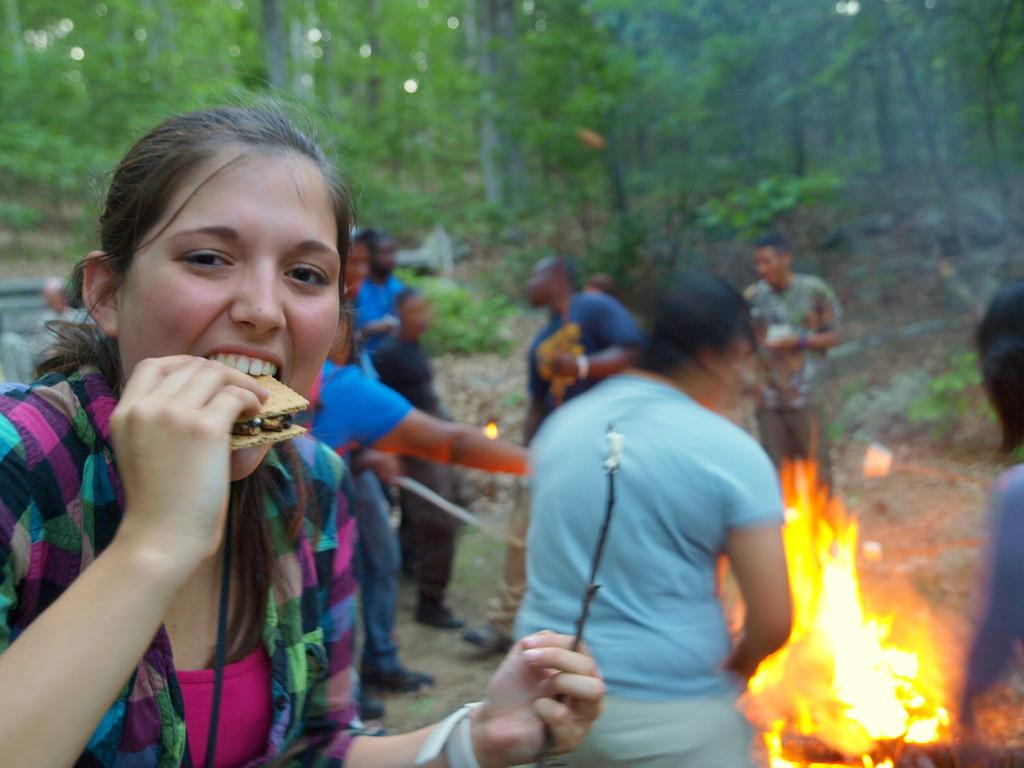What is the main subject of the image? The main subject of the image is a group of people. Can you describe one person in the group? Yes, there is a woman in the image. What is the woman doing in the image? The woman is eating. What can be seen in the background of the image? There is fire and trees visible in the background of the image. What type of plastic is being used by the woman to eat in the image? There is no plastic visible in the image; the woman is eating with a fork or spoon, as seen in the image. 